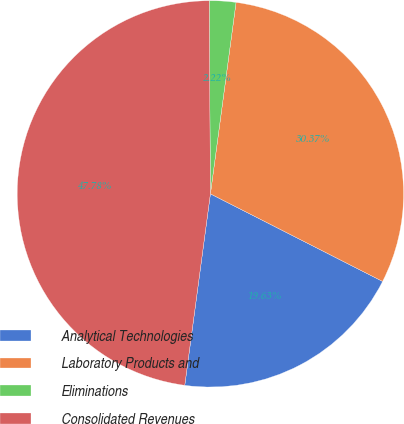<chart> <loc_0><loc_0><loc_500><loc_500><pie_chart><fcel>Analytical Technologies<fcel>Laboratory Products and<fcel>Eliminations<fcel>Consolidated Revenues<nl><fcel>19.63%<fcel>30.37%<fcel>2.22%<fcel>47.78%<nl></chart> 